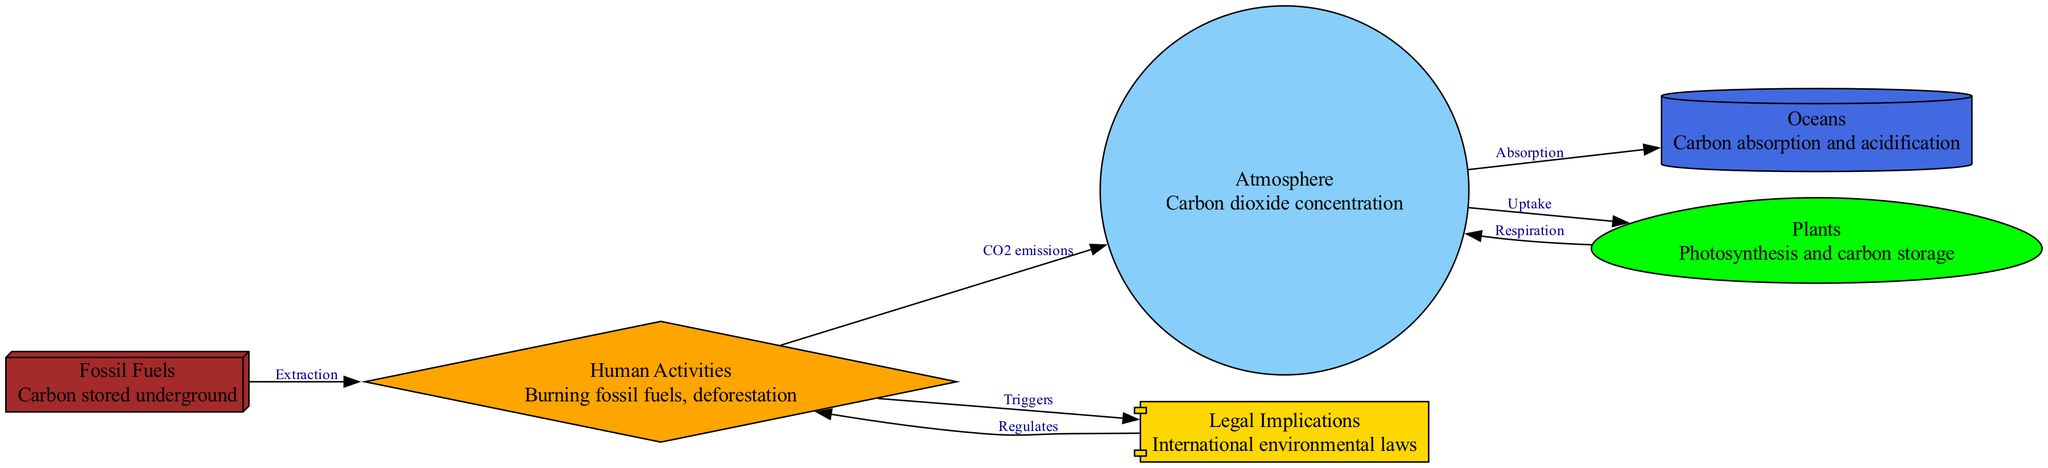What node represents the process of carbon absorption by oceans? The diagram lists the node "Oceans," which indicates its role in carbon absorption and acidification.
Answer: Oceans What triggers legal implications in the carbon cycle? According to the diagram, the "Human Activities" node has a relationship labeled "Triggers" that connects to the "Legal Implications" node. This implies that human actions, such as burning fossil fuels and deforestation, lead to legal concerns.
Answer: Human Activities How many edges are there in the diagram? By counting the connections (edges) between the nodes, there are a total of 7 distinct edges shown in the diagram.
Answer: 7 What relationship exists between the atmosphere and the plants? The diagram demonstrates a relationship between "Atmosphere" and "Plants" labeled as "Uptake," indicating that carbon dioxide is absorbed by plants from the atmosphere through photosynthesis.
Answer: Uptake What is the shape of the node representing fossil fuels? The diagram specifies that the node for "Fossil Fuels" has a 3D box shape, defined in the node styles.
Answer: Box3D What role do human activities have in the carbon cycle? In the diagram, "Human Activities" have multiple relationships, including CO2 emissions released into the atmosphere and acting as triggers for legal implications, indicating a significant influence on the carbon cycle.
Answer: Significant influence What process do plants contribute back to the atmosphere? The diagram shows a bidirectional relationship where "Plants" contribute to the atmosphere via "Respiration," releasing carbon dioxide back into the air.
Answer: Respiration Which node is specifically focused on international environmental laws? The node titled "Legal Implications" explicitly references international environmental laws within the context of the carbon cycle.
Answer: Legal Implications 